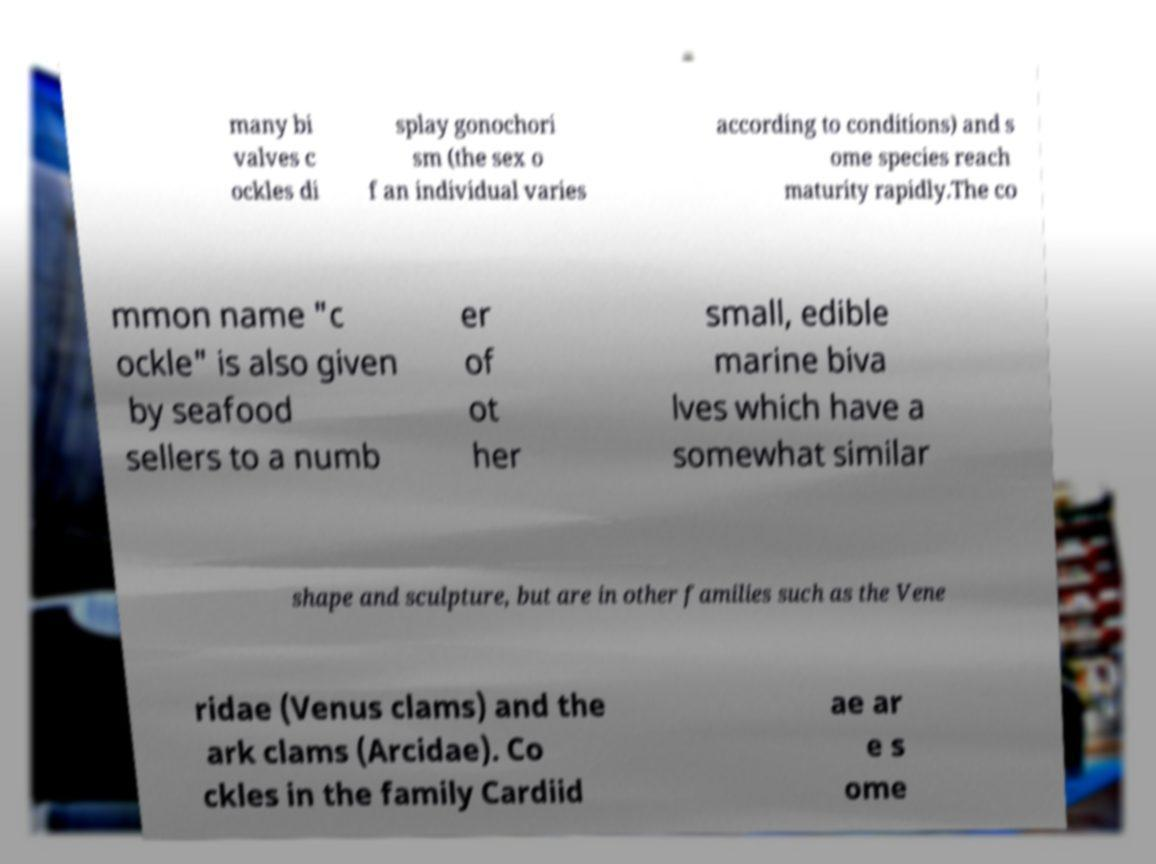Please read and relay the text visible in this image. What does it say? many bi valves c ockles di splay gonochori sm (the sex o f an individual varies according to conditions) and s ome species reach maturity rapidly.The co mmon name "c ockle" is also given by seafood sellers to a numb er of ot her small, edible marine biva lves which have a somewhat similar shape and sculpture, but are in other families such as the Vene ridae (Venus clams) and the ark clams (Arcidae). Co ckles in the family Cardiid ae ar e s ome 